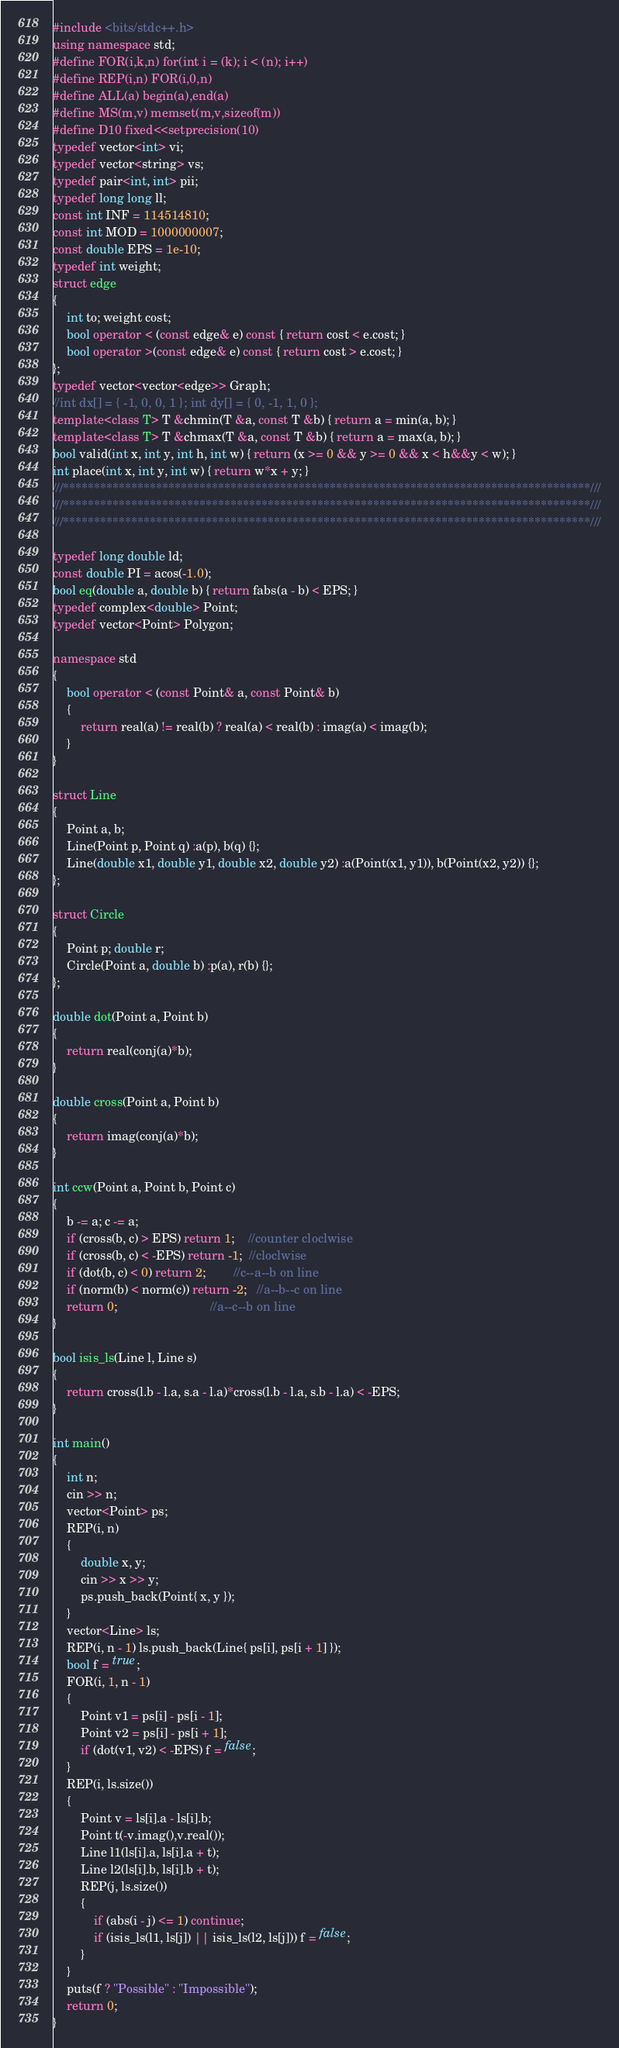<code> <loc_0><loc_0><loc_500><loc_500><_C++_>#include <bits/stdc++.h>
using namespace std;
#define FOR(i,k,n) for(int i = (k); i < (n); i++)
#define REP(i,n) FOR(i,0,n)
#define ALL(a) begin(a),end(a)
#define MS(m,v) memset(m,v,sizeof(m))
#define D10 fixed<<setprecision(10)
typedef vector<int> vi;
typedef vector<string> vs;
typedef pair<int, int> pii;
typedef long long ll;
const int INF = 114514810;
const int MOD = 1000000007;
const double EPS = 1e-10;
typedef int weight;
struct edge
{
	int to; weight cost;
	bool operator < (const edge& e) const { return cost < e.cost; }
	bool operator >(const edge& e) const { return cost > e.cost; }
};
typedef vector<vector<edge>> Graph;
//int dx[] = { -1, 0, 0, 1 }; int dy[] = { 0, -1, 1, 0 };
template<class T> T &chmin(T &a, const T &b) { return a = min(a, b); }
template<class T> T &chmax(T &a, const T &b) { return a = max(a, b); }
bool valid(int x, int y, int h, int w) { return (x >= 0 && y >= 0 && x < h&&y < w); }
int place(int x, int y, int w) { return w*x + y; }
///*************************************************************************************///
///*************************************************************************************///
///*************************************************************************************///

typedef long double ld;
const double PI = acos(-1.0);
bool eq(double a, double b) { return fabs(a - b) < EPS; }
typedef complex<double> Point;
typedef vector<Point> Polygon;

namespace std
{
	bool operator < (const Point& a, const Point& b)
	{
		return real(a) != real(b) ? real(a) < real(b) : imag(a) < imag(b);
	}
}

struct Line
{
	Point a, b;
	Line(Point p, Point q) :a(p), b(q) {};
	Line(double x1, double y1, double x2, double y2) :a(Point(x1, y1)), b(Point(x2, y2)) {};
};

struct Circle
{
	Point p; double r;
	Circle(Point a, double b) :p(a), r(b) {};
};

double dot(Point a, Point b)
{
	return real(conj(a)*b);
}

double cross(Point a, Point b)
{
	return imag(conj(a)*b);
}

int ccw(Point a, Point b, Point c)
{
	b -= a; c -= a;
	if (cross(b, c) > EPS) return 1;    //counter cloclwise
	if (cross(b, c) < -EPS) return -1;  //cloclwise
	if (dot(b, c) < 0) return 2;        //c--a--b on line 
	if (norm(b) < norm(c)) return -2;   //a--b--c on line
	return 0;                           //a--c--b on line
}

bool isis_ls(Line l, Line s)
{
	return cross(l.b - l.a, s.a - l.a)*cross(l.b - l.a, s.b - l.a) < -EPS;
}

int main()
{
	int n;
	cin >> n;
	vector<Point> ps;
	REP(i, n)
	{
		double x, y;
		cin >> x >> y;
		ps.push_back(Point{ x, y });
	}
	vector<Line> ls;
	REP(i, n - 1) ls.push_back(Line{ ps[i], ps[i + 1] });
	bool f = true;
	FOR(i, 1, n - 1)
	{
		Point v1 = ps[i] - ps[i - 1];
		Point v2 = ps[i] - ps[i + 1];
		if (dot(v1, v2) < -EPS) f = false;
	}
	REP(i, ls.size())
	{
		Point v = ls[i].a - ls[i].b;
		Point t(-v.imag(),v.real());
		Line l1(ls[i].a, ls[i].a + t);
		Line l2(ls[i].b, ls[i].b + t);
		REP(j, ls.size())
		{
			if (abs(i - j) <= 1) continue;
			if (isis_ls(l1, ls[j]) || isis_ls(l2, ls[j])) f = false;
		}
	}
	puts(f ? "Possible" : "Impossible");
	return 0;
}</code> 